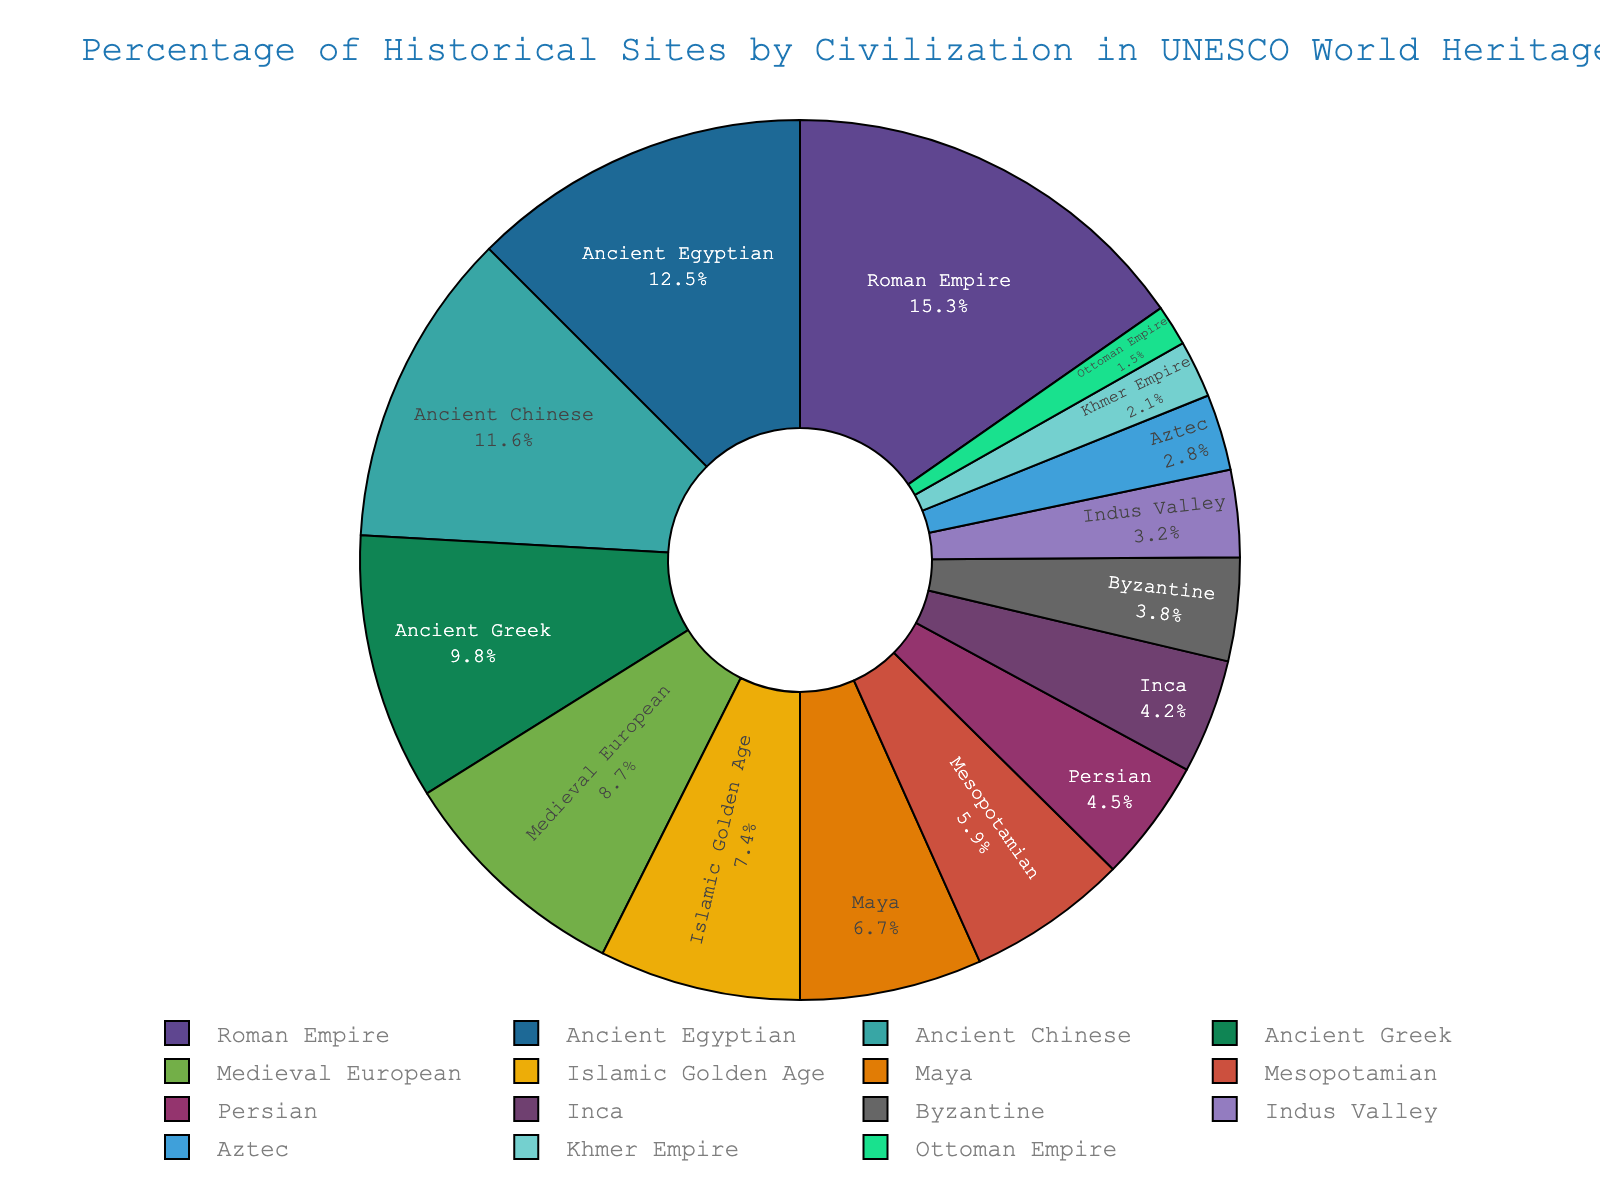What's the largest segment in the pie chart? The largest segment in the pie chart is represented by the Roman Empire, which is highlighted with the largest percentage.
Answer: Roman Empire Which civilizations together contribute more than 20% of the historical sites? Adding the percentages of Ancient Egyptian (12.5%) and Maya (6.7%) results in 19.2%, which is less than 20%. Adding Roman Empire (15.3%) and any other civilization (Ancient Greek at 9.8% for example) exceeds 20%.
Answer: Roman Empire and Ancient Greek Which civilization has a larger percentage of historical sites, the Islamic Golden Age or the Byzantine? The Islamic Golden Age segment is larger at 7.4% compared to the Byzantine segment at 3.8%.
Answer: Islamic Golden Age How does the percentage of Inca sites compare with that of the Aztec sites? The Inca civilization represents 4.2% of the historical sites, whereas the Aztec civilization represents 2.8%. Therefore, the Inca percentage is higher.
Answer: Inca What is the difference in percentage between Ancient Chinese and Ancient Greek civilizations? The percentage for Ancient Chinese civilization is 11.6% and for Ancient Greek is 9.8%. Subtracting 9.8 from 11.6 gives 1.8.
Answer: 1.8% What's the total percentage of historical sites for the top three civilizations? The top three civilizations are Roman Empire (15.3%), Ancient Egyptian (12.5%), and Ancient Chinese (11.6%). Adding them together, 15.3 + 12.5 + 11.6 equals 39.4.
Answer: 39.4% Which civilization has the smallest percentage of historical sites? The smallest segment in the pie chart represents the Ottoman Empire with 1.5%.
Answer: Ottoman Empire What percentage do Medieval European and Mesopotamian civilizations contribute together? The percentages for Medieval European and Mesopotamian are 8.7% and 5.9%, respectively. Adding them together, 8.7 + 5.9 equals 14.6.
Answer: 14.6% How many civilizations have a percentage greater than 10%? The civilizations with greater than 10% are the Roman Empire (15.3%), Ancient Egyptian (12.5%), and Ancient Chinese (11.6%). There are three such civilizations.
Answer: 3 What is the combined percentage of the three least represented civilizations? The three least represented civilizations are Ottoman Empire (1.5%), Khmer Empire (2.1%), and Indus Valley (3.2%). Adding them together, 1.5 + 2.1 + 3.2 equals 6.8%.
Answer: 6.8% 